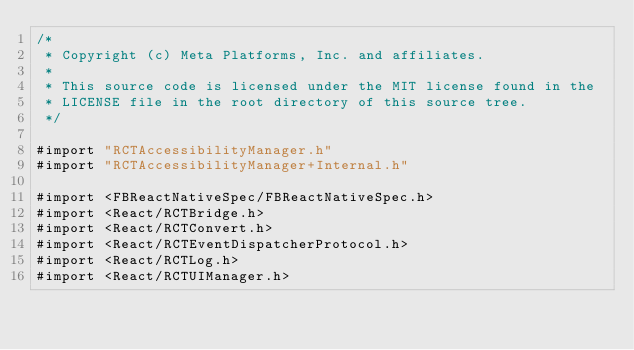Convert code to text. <code><loc_0><loc_0><loc_500><loc_500><_ObjectiveC_>/*
 * Copyright (c) Meta Platforms, Inc. and affiliates.
 *
 * This source code is licensed under the MIT license found in the
 * LICENSE file in the root directory of this source tree.
 */

#import "RCTAccessibilityManager.h"
#import "RCTAccessibilityManager+Internal.h"

#import <FBReactNativeSpec/FBReactNativeSpec.h>
#import <React/RCTBridge.h>
#import <React/RCTConvert.h>
#import <React/RCTEventDispatcherProtocol.h>
#import <React/RCTLog.h>
#import <React/RCTUIManager.h>
</code> 